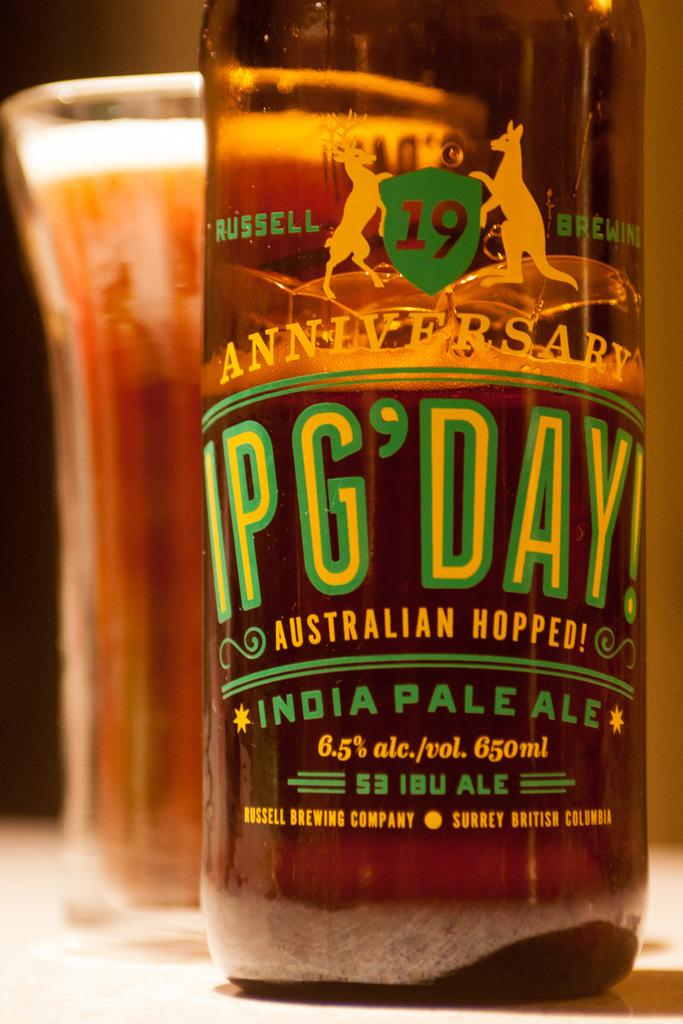<image>
Relay a brief, clear account of the picture shown. A bottle of India Pale Ale from Australian Hopped! is shown in front of a glass of the beverage. 